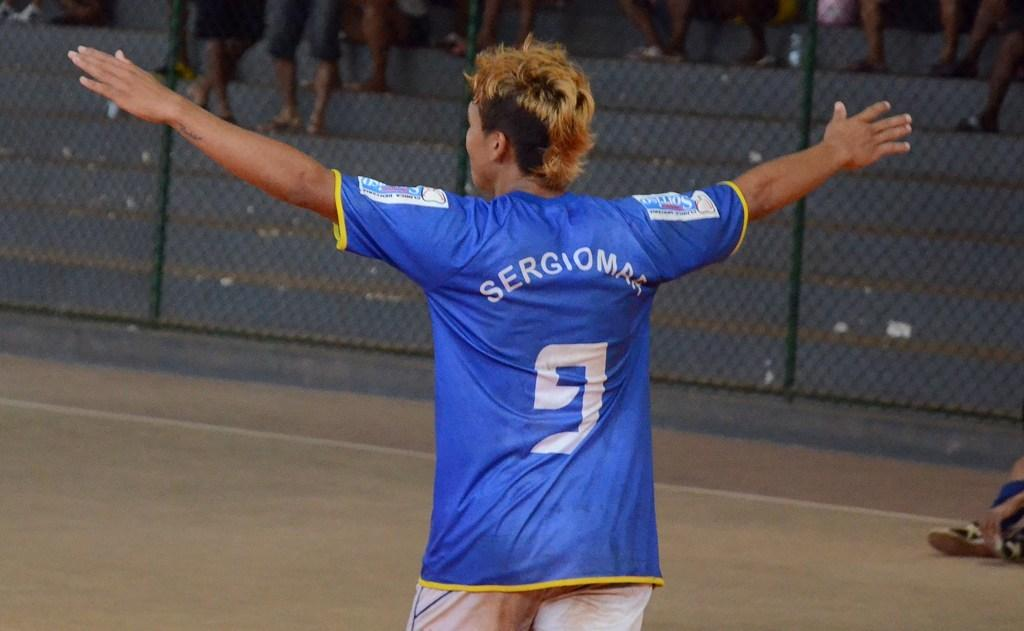<image>
Give a short and clear explanation of the subsequent image. a sportsman with arms open wide in a blue jersey saying Sergiomar 9 